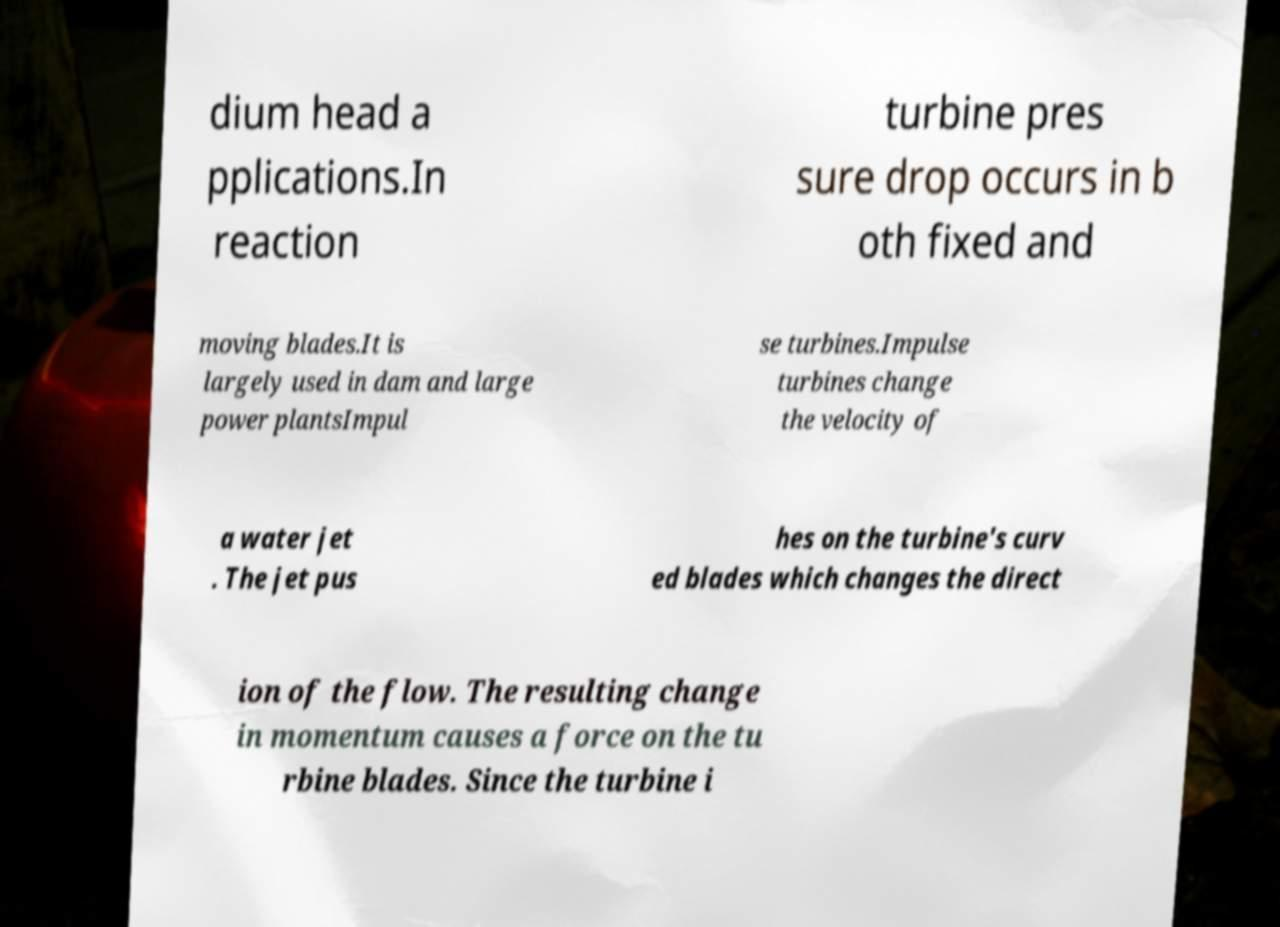Please identify and transcribe the text found in this image. dium head a pplications.In reaction turbine pres sure drop occurs in b oth fixed and moving blades.It is largely used in dam and large power plantsImpul se turbines.Impulse turbines change the velocity of a water jet . The jet pus hes on the turbine's curv ed blades which changes the direct ion of the flow. The resulting change in momentum causes a force on the tu rbine blades. Since the turbine i 